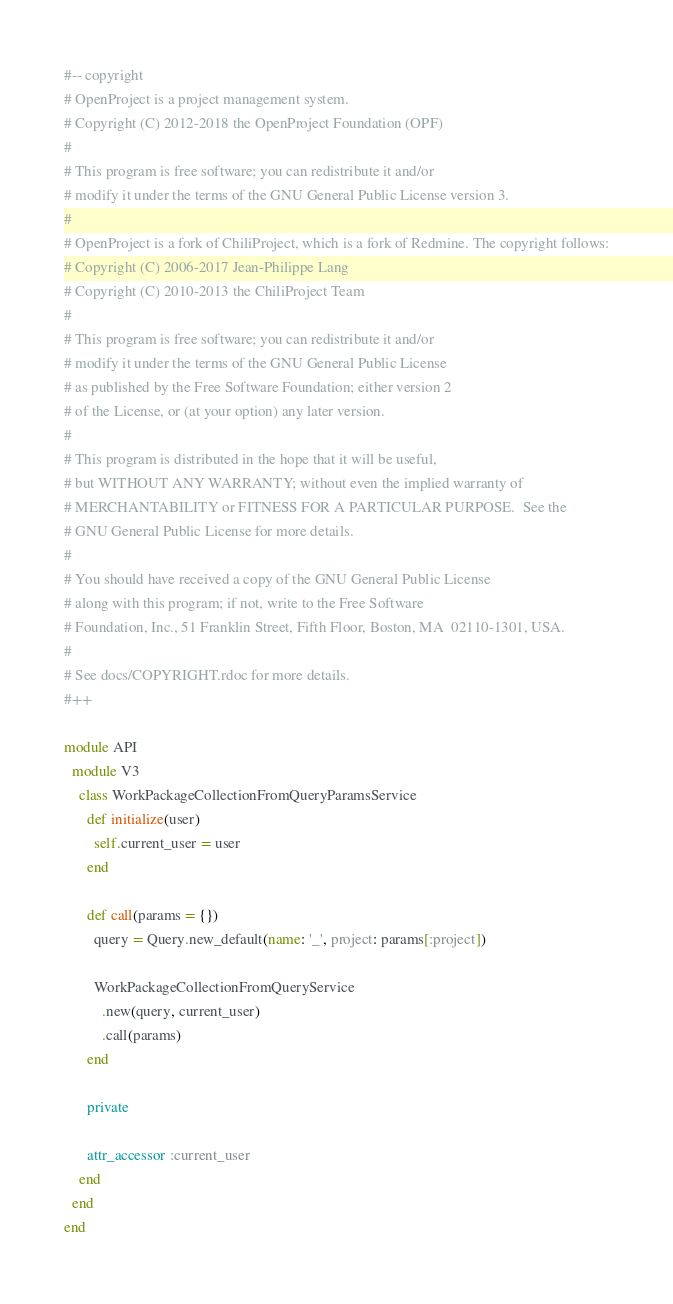<code> <loc_0><loc_0><loc_500><loc_500><_Ruby_>#-- copyright
# OpenProject is a project management system.
# Copyright (C) 2012-2018 the OpenProject Foundation (OPF)
#
# This program is free software; you can redistribute it and/or
# modify it under the terms of the GNU General Public License version 3.
#
# OpenProject is a fork of ChiliProject, which is a fork of Redmine. The copyright follows:
# Copyright (C) 2006-2017 Jean-Philippe Lang
# Copyright (C) 2010-2013 the ChiliProject Team
#
# This program is free software; you can redistribute it and/or
# modify it under the terms of the GNU General Public License
# as published by the Free Software Foundation; either version 2
# of the License, or (at your option) any later version.
#
# This program is distributed in the hope that it will be useful,
# but WITHOUT ANY WARRANTY; without even the implied warranty of
# MERCHANTABILITY or FITNESS FOR A PARTICULAR PURPOSE.  See the
# GNU General Public License for more details.
#
# You should have received a copy of the GNU General Public License
# along with this program; if not, write to the Free Software
# Foundation, Inc., 51 Franklin Street, Fifth Floor, Boston, MA  02110-1301, USA.
#
# See docs/COPYRIGHT.rdoc for more details.
#++

module API
  module V3
    class WorkPackageCollectionFromQueryParamsService
      def initialize(user)
        self.current_user = user
      end

      def call(params = {})
        query = Query.new_default(name: '_', project: params[:project])

        WorkPackageCollectionFromQueryService
          .new(query, current_user)
          .call(params)
      end

      private

      attr_accessor :current_user
    end
  end
end
</code> 